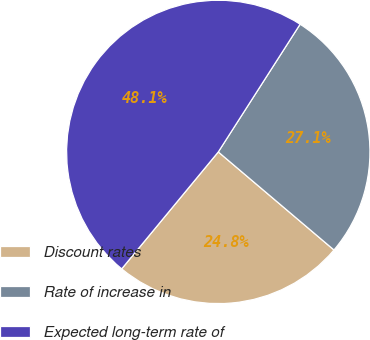Convert chart to OTSL. <chart><loc_0><loc_0><loc_500><loc_500><pie_chart><fcel>Discount rates<fcel>Rate of increase in<fcel>Expected long-term rate of<nl><fcel>24.8%<fcel>27.12%<fcel>48.08%<nl></chart> 